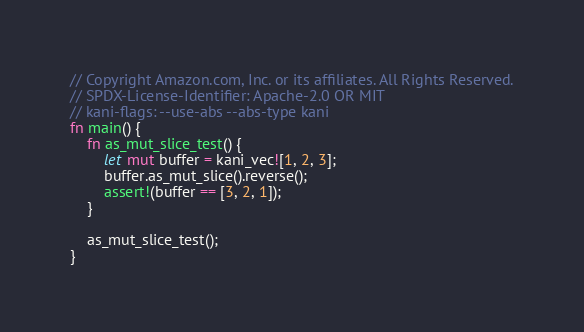Convert code to text. <code><loc_0><loc_0><loc_500><loc_500><_Rust_>// Copyright Amazon.com, Inc. or its affiliates. All Rights Reserved.
// SPDX-License-Identifier: Apache-2.0 OR MIT
// kani-flags: --use-abs --abs-type kani
fn main() {
    fn as_mut_slice_test() {
        let mut buffer = kani_vec![1, 2, 3];
        buffer.as_mut_slice().reverse();
        assert!(buffer == [3, 2, 1]);
    }

    as_mut_slice_test();
}
</code> 